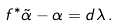Convert formula to latex. <formula><loc_0><loc_0><loc_500><loc_500>f ^ { * } \tilde { \alpha } - \alpha = d \lambda \, .</formula> 